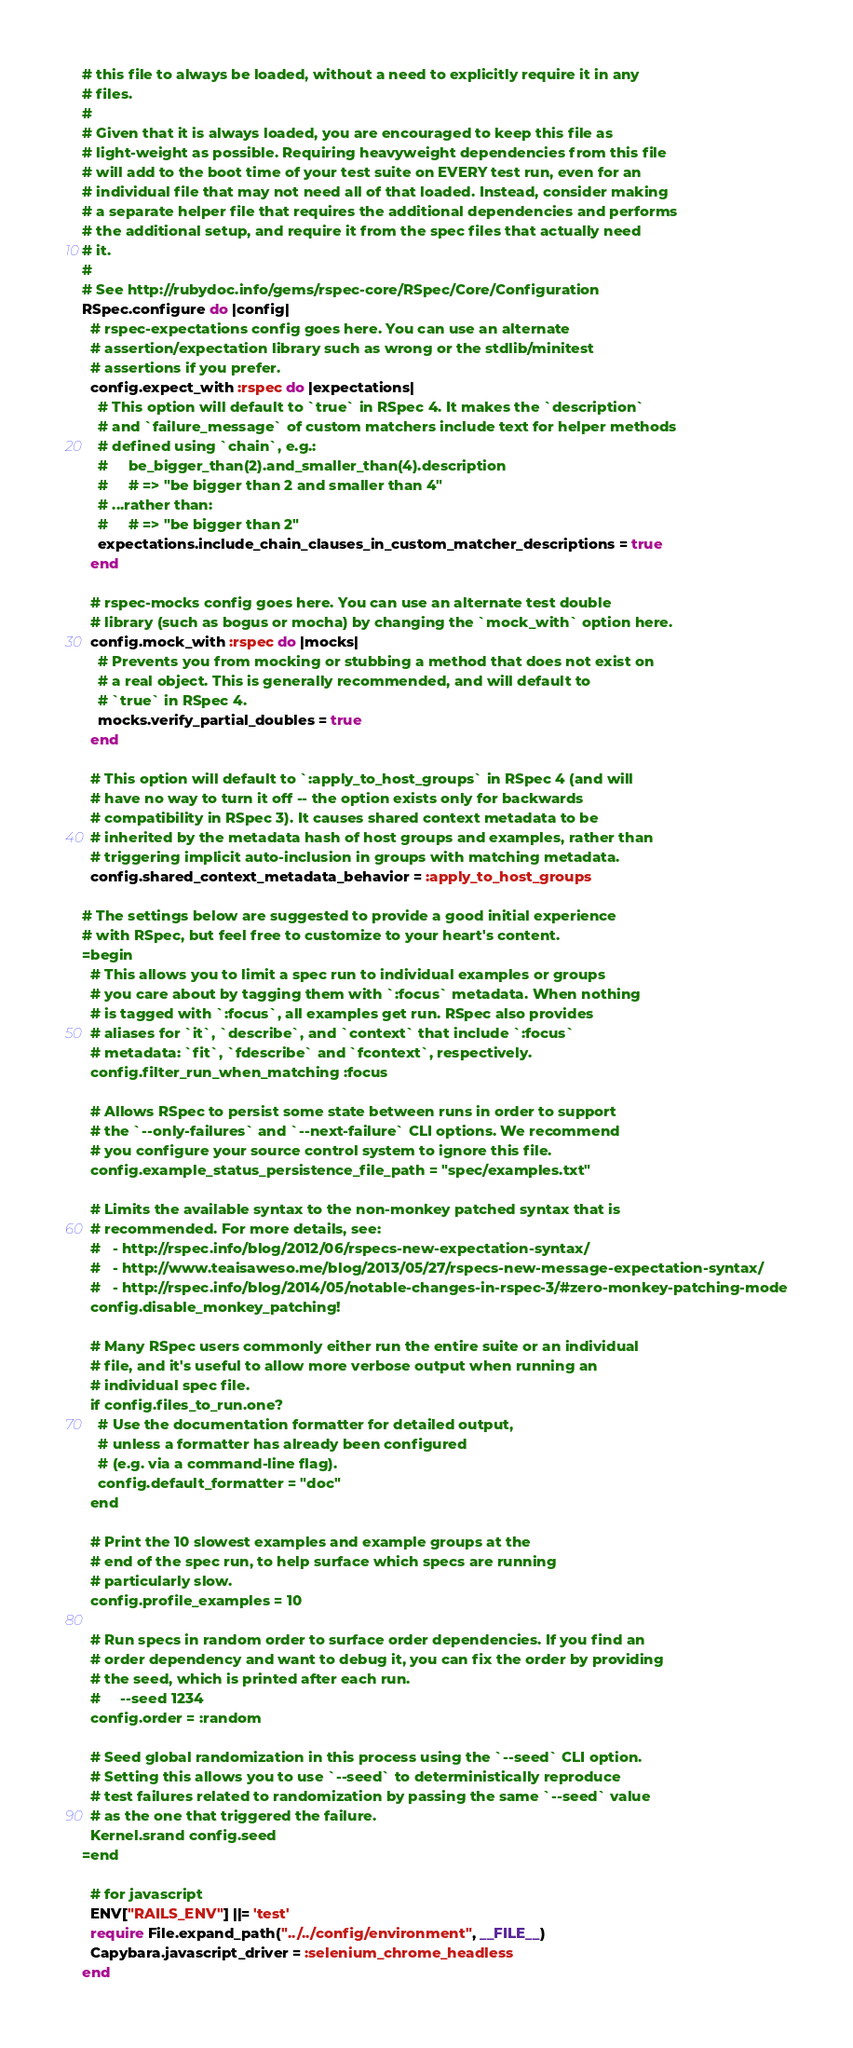Convert code to text. <code><loc_0><loc_0><loc_500><loc_500><_Ruby_># this file to always be loaded, without a need to explicitly require it in any
# files.
#
# Given that it is always loaded, you are encouraged to keep this file as
# light-weight as possible. Requiring heavyweight dependencies from this file
# will add to the boot time of your test suite on EVERY test run, even for an
# individual file that may not need all of that loaded. Instead, consider making
# a separate helper file that requires the additional dependencies and performs
# the additional setup, and require it from the spec files that actually need
# it.
#
# See http://rubydoc.info/gems/rspec-core/RSpec/Core/Configuration
RSpec.configure do |config|
  # rspec-expectations config goes here. You can use an alternate
  # assertion/expectation library such as wrong or the stdlib/minitest
  # assertions if you prefer.
  config.expect_with :rspec do |expectations|
    # This option will default to `true` in RSpec 4. It makes the `description`
    # and `failure_message` of custom matchers include text for helper methods
    # defined using `chain`, e.g.:
    #     be_bigger_than(2).and_smaller_than(4).description
    #     # => "be bigger than 2 and smaller than 4"
    # ...rather than:
    #     # => "be bigger than 2"
    expectations.include_chain_clauses_in_custom_matcher_descriptions = true
  end

  # rspec-mocks config goes here. You can use an alternate test double
  # library (such as bogus or mocha) by changing the `mock_with` option here.
  config.mock_with :rspec do |mocks|
    # Prevents you from mocking or stubbing a method that does not exist on
    # a real object. This is generally recommended, and will default to
    # `true` in RSpec 4.
    mocks.verify_partial_doubles = true
  end

  # This option will default to `:apply_to_host_groups` in RSpec 4 (and will
  # have no way to turn it off -- the option exists only for backwards
  # compatibility in RSpec 3). It causes shared context metadata to be
  # inherited by the metadata hash of host groups and examples, rather than
  # triggering implicit auto-inclusion in groups with matching metadata.
  config.shared_context_metadata_behavior = :apply_to_host_groups

# The settings below are suggested to provide a good initial experience
# with RSpec, but feel free to customize to your heart's content.
=begin
  # This allows you to limit a spec run to individual examples or groups
  # you care about by tagging them with `:focus` metadata. When nothing
  # is tagged with `:focus`, all examples get run. RSpec also provides
  # aliases for `it`, `describe`, and `context` that include `:focus`
  # metadata: `fit`, `fdescribe` and `fcontext`, respectively.
  config.filter_run_when_matching :focus

  # Allows RSpec to persist some state between runs in order to support
  # the `--only-failures` and `--next-failure` CLI options. We recommend
  # you configure your source control system to ignore this file.
  config.example_status_persistence_file_path = "spec/examples.txt"

  # Limits the available syntax to the non-monkey patched syntax that is
  # recommended. For more details, see:
  #   - http://rspec.info/blog/2012/06/rspecs-new-expectation-syntax/
  #   - http://www.teaisaweso.me/blog/2013/05/27/rspecs-new-message-expectation-syntax/
  #   - http://rspec.info/blog/2014/05/notable-changes-in-rspec-3/#zero-monkey-patching-mode
  config.disable_monkey_patching!

  # Many RSpec users commonly either run the entire suite or an individual
  # file, and it's useful to allow more verbose output when running an
  # individual spec file.
  if config.files_to_run.one?
    # Use the documentation formatter for detailed output,
    # unless a formatter has already been configured
    # (e.g. via a command-line flag).
    config.default_formatter = "doc"
  end

  # Print the 10 slowest examples and example groups at the
  # end of the spec run, to help surface which specs are running
  # particularly slow.
  config.profile_examples = 10

  # Run specs in random order to surface order dependencies. If you find an
  # order dependency and want to debug it, you can fix the order by providing
  # the seed, which is printed after each run.
  #     --seed 1234
  config.order = :random

  # Seed global randomization in this process using the `--seed` CLI option.
  # Setting this allows you to use `--seed` to deterministically reproduce
  # test failures related to randomization by passing the same `--seed` value
  # as the one that triggered the failure.
  Kernel.srand config.seed
=end

  # for javascript
  ENV["RAILS_ENV"] ||= 'test'
  require File.expand_path("../../config/environment", __FILE__)
  Capybara.javascript_driver = :selenium_chrome_headless
end
</code> 